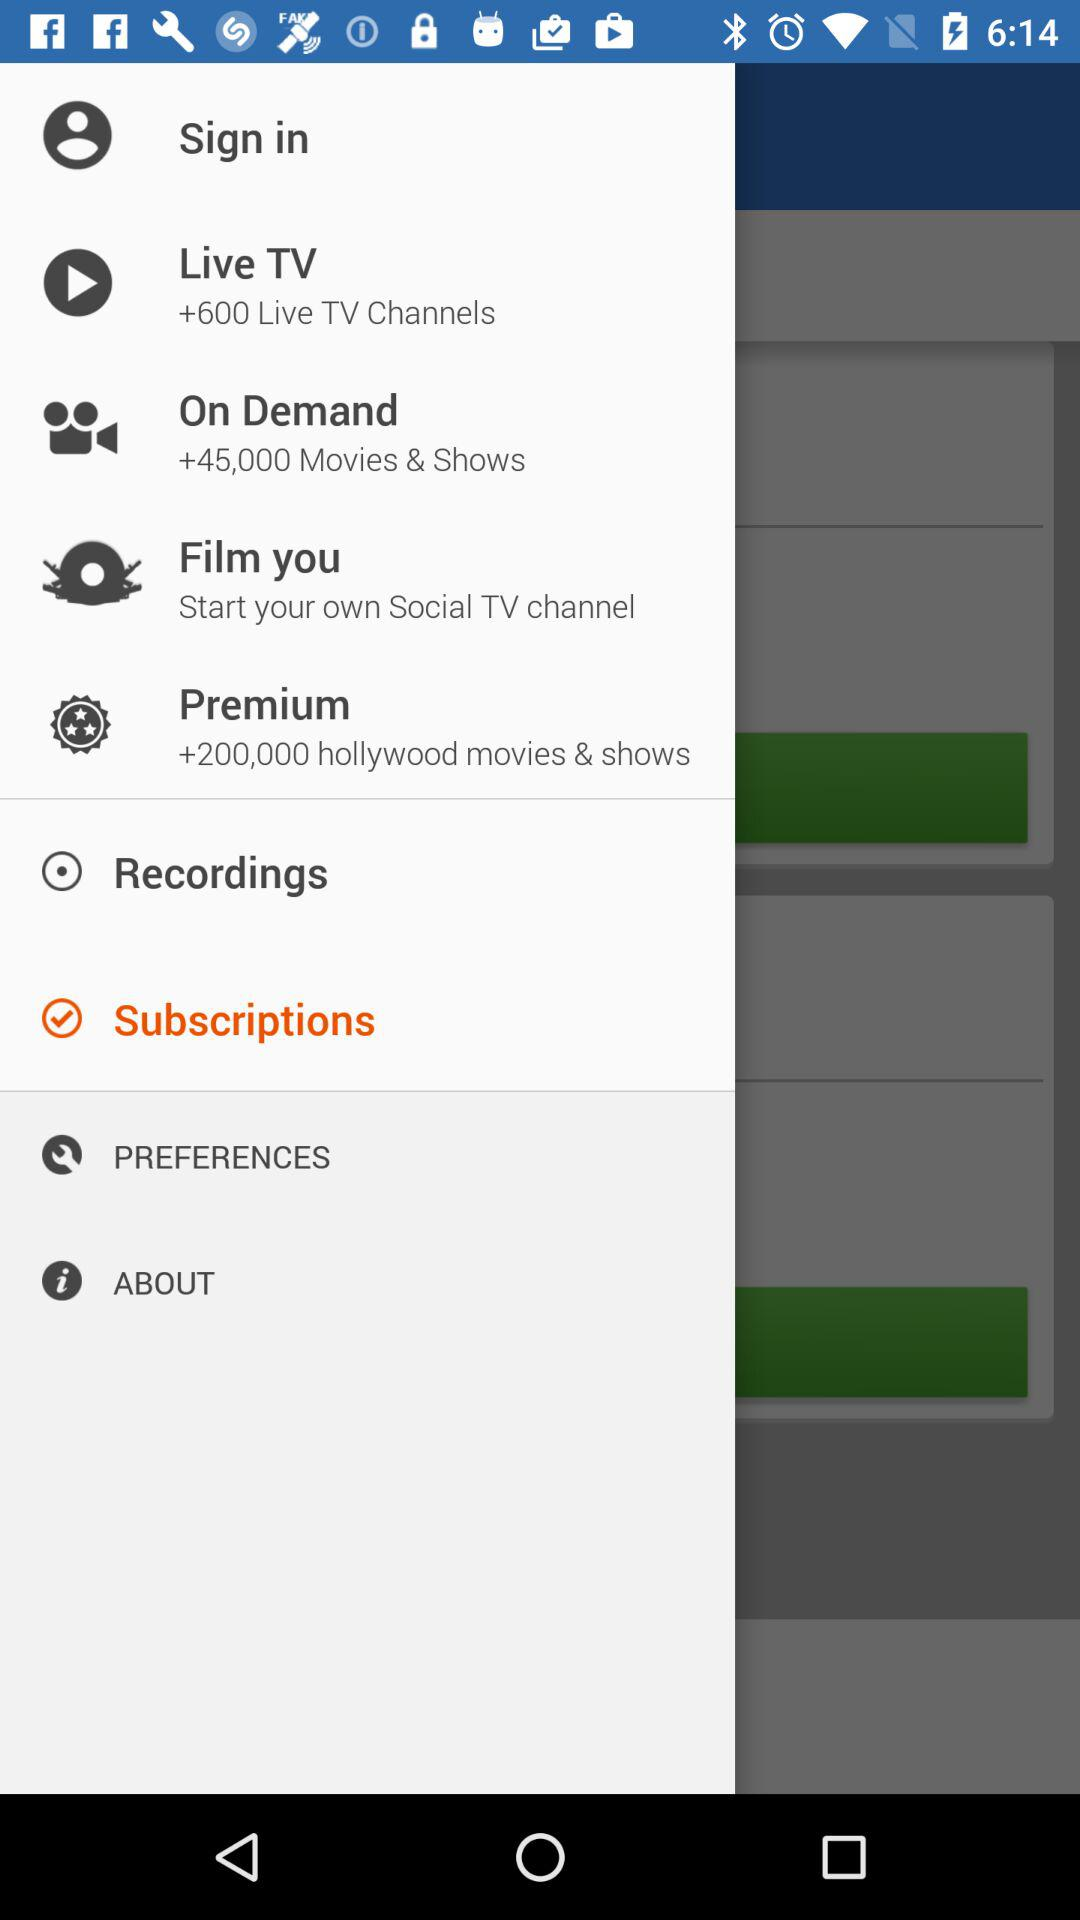How many items are there before the first subscription item?
Answer the question using a single word or phrase. 6 